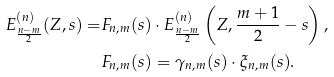<formula> <loc_0><loc_0><loc_500><loc_500>E _ { \frac { n - m } { 2 } } ^ { ( n ) } ( Z , s ) = & F _ { n , m } ( s ) \cdot E _ { \frac { n - m } { 2 } } ^ { ( n ) } \left ( Z , \frac { m + 1 } { 2 } - s \right ) , \\ & F _ { n , m } ( s ) = \gamma _ { n , m } ( s ) \cdot \xi _ { n , m } ( s ) .</formula> 